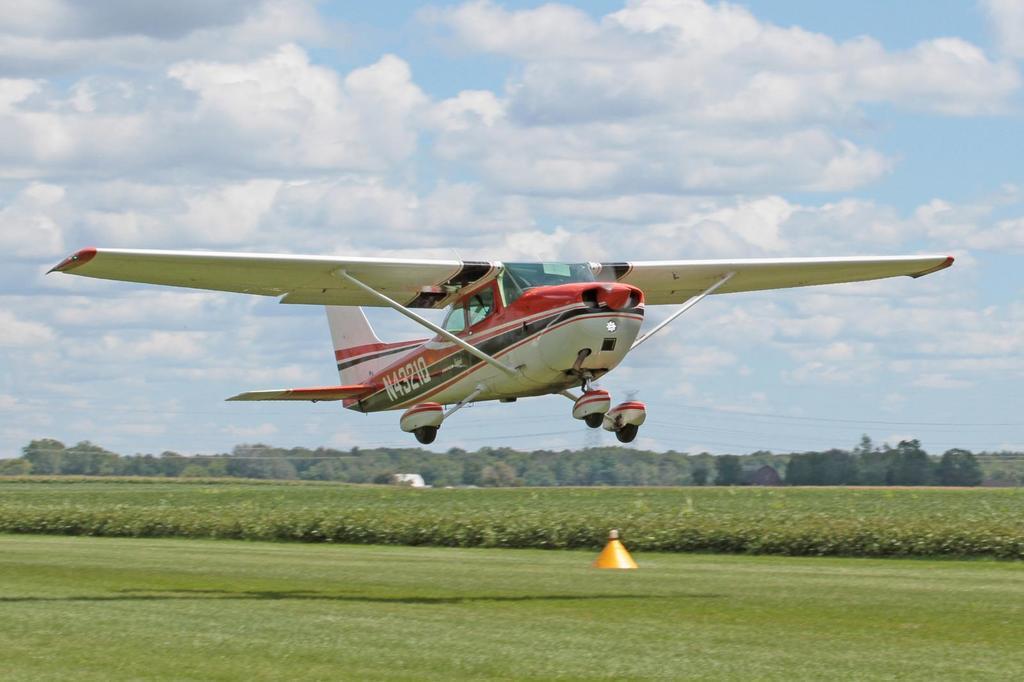How would you summarize this image in a sentence or two? In this image I can see an airplane flying in the air. At the bottom, I can see the grass and plants. In the background there are many trees. At the top of the image I can see the sky and clouds. 